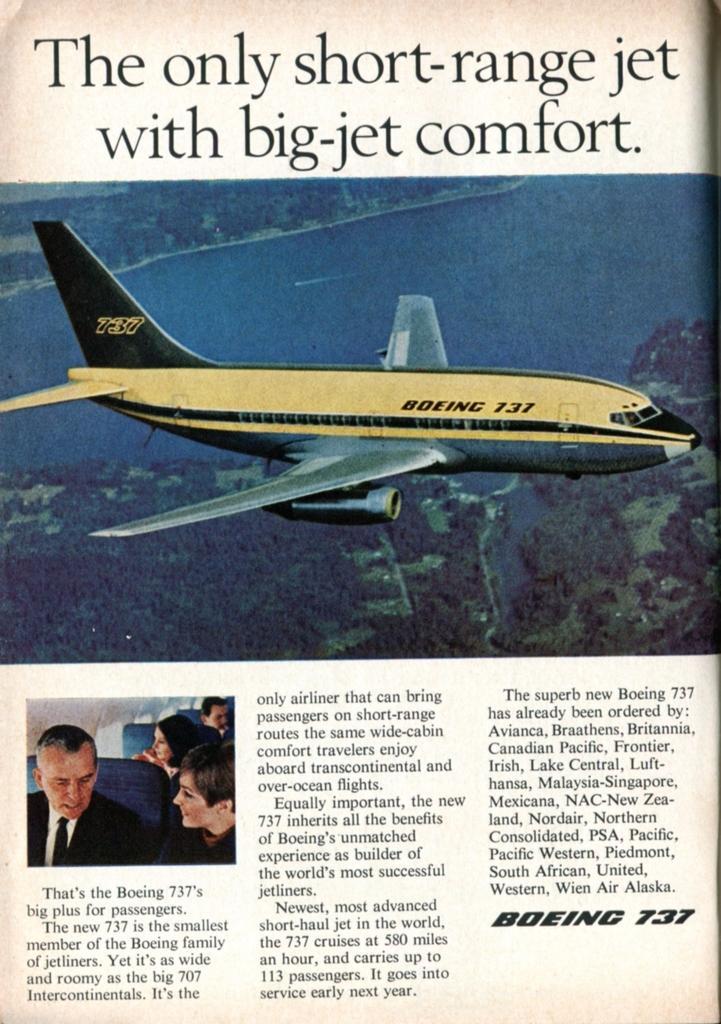In one or two sentences, can you explain what this image depicts? We can see poster,in this poster we can see airplane and people. 